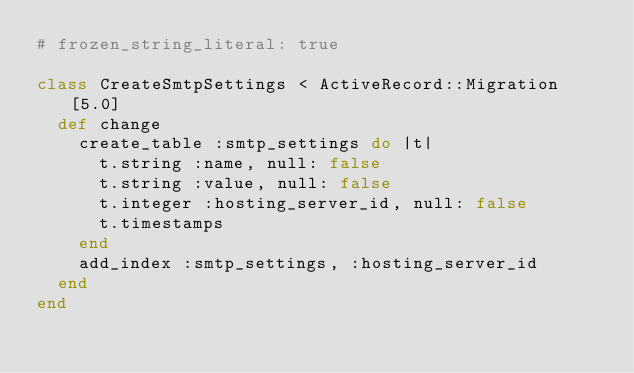<code> <loc_0><loc_0><loc_500><loc_500><_Ruby_># frozen_string_literal: true

class CreateSmtpSettings < ActiveRecord::Migration[5.0]
  def change
    create_table :smtp_settings do |t|
      t.string :name, null: false
      t.string :value, null: false
      t.integer :hosting_server_id, null: false
      t.timestamps
    end
    add_index :smtp_settings, :hosting_server_id
  end
end
</code> 